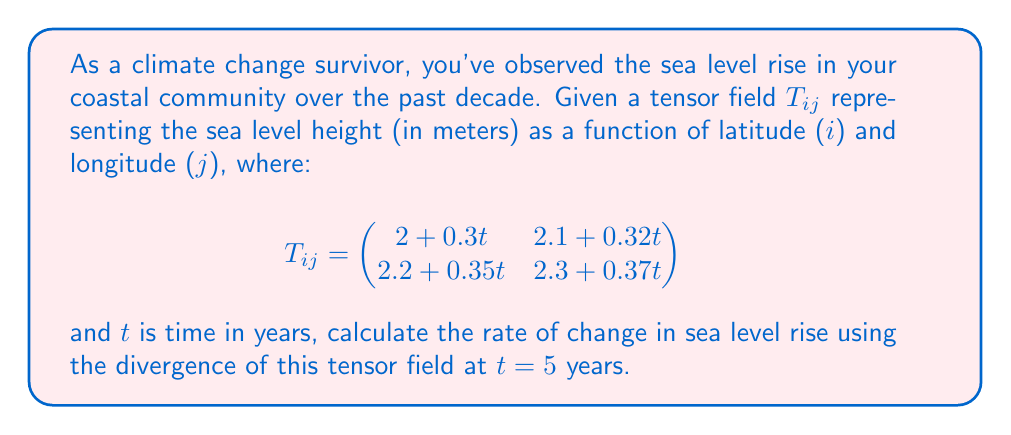Can you answer this question? To solve this problem, we'll follow these steps:

1) The divergence of a tensor field in 2D is given by:

   $$\text{div}(T) = \frac{\partial T_{11}}{\partial x} + \frac{\partial T_{22}}{\partial y}$$

2) In our case, $T_{11} = 2 + 0.3t$ and $T_{22} = 2.3 + 0.37t$

3) We need to find $\frac{\partial T_{11}}{\partial x}$ and $\frac{\partial T_{22}}{\partial y}$:

   $\frac{\partial T_{11}}{\partial x} = 0.3$ (with respect to time)
   $\frac{\partial T_{22}}{\partial y} = 0.37$ (with respect to time)

4) Now, we can calculate the divergence:

   $$\text{div}(T) = 0.3 + 0.37 = 0.67$$

5) This divergence represents the rate of change in sea level rise in meters per year.

6) The question asks for the rate at $t = 5$ years, but since our result is constant with respect to time, the answer is the same for all $t$.
Answer: 0.67 m/year 